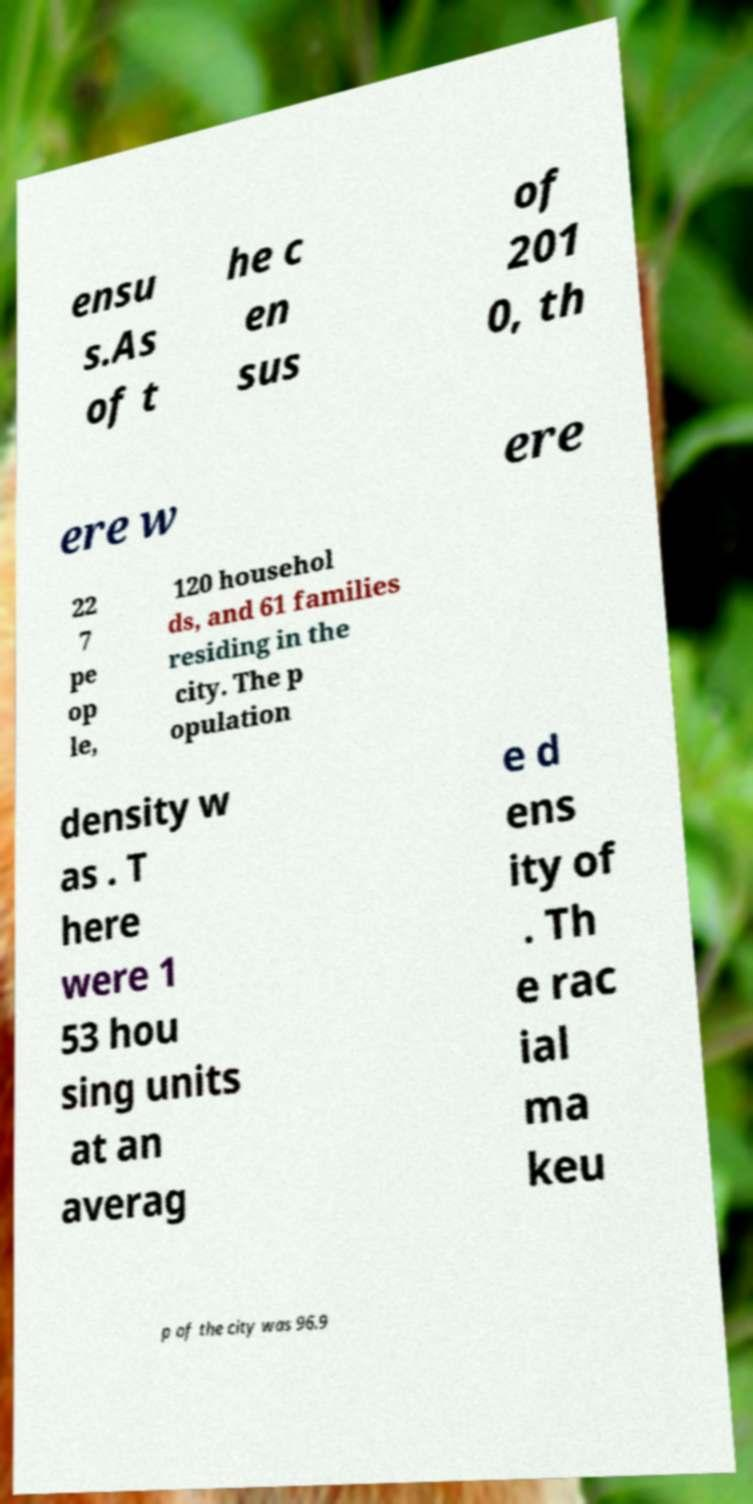Please identify and transcribe the text found in this image. ensu s.As of t he c en sus of 201 0, th ere w ere 22 7 pe op le, 120 househol ds, and 61 families residing in the city. The p opulation density w as . T here were 1 53 hou sing units at an averag e d ens ity of . Th e rac ial ma keu p of the city was 96.9 